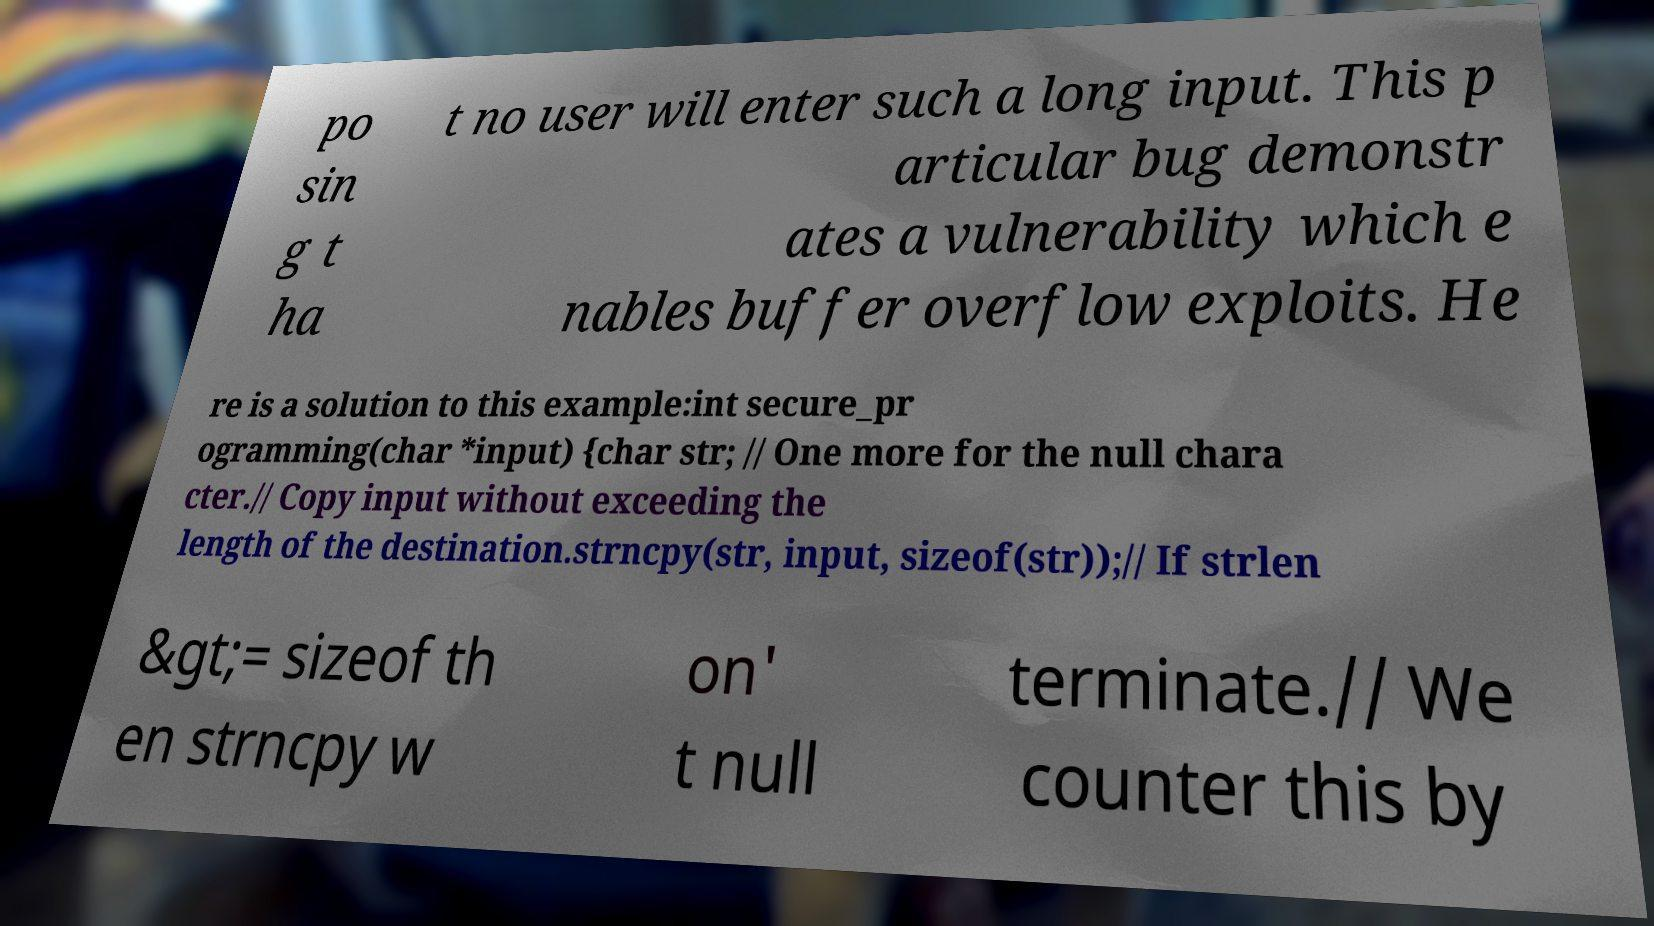Could you extract and type out the text from this image? po sin g t ha t no user will enter such a long input. This p articular bug demonstr ates a vulnerability which e nables buffer overflow exploits. He re is a solution to this example:int secure_pr ogramming(char *input) {char str; // One more for the null chara cter.// Copy input without exceeding the length of the destination.strncpy(str, input, sizeof(str));// If strlen &gt;= sizeof th en strncpy w on' t null terminate.// We counter this by 